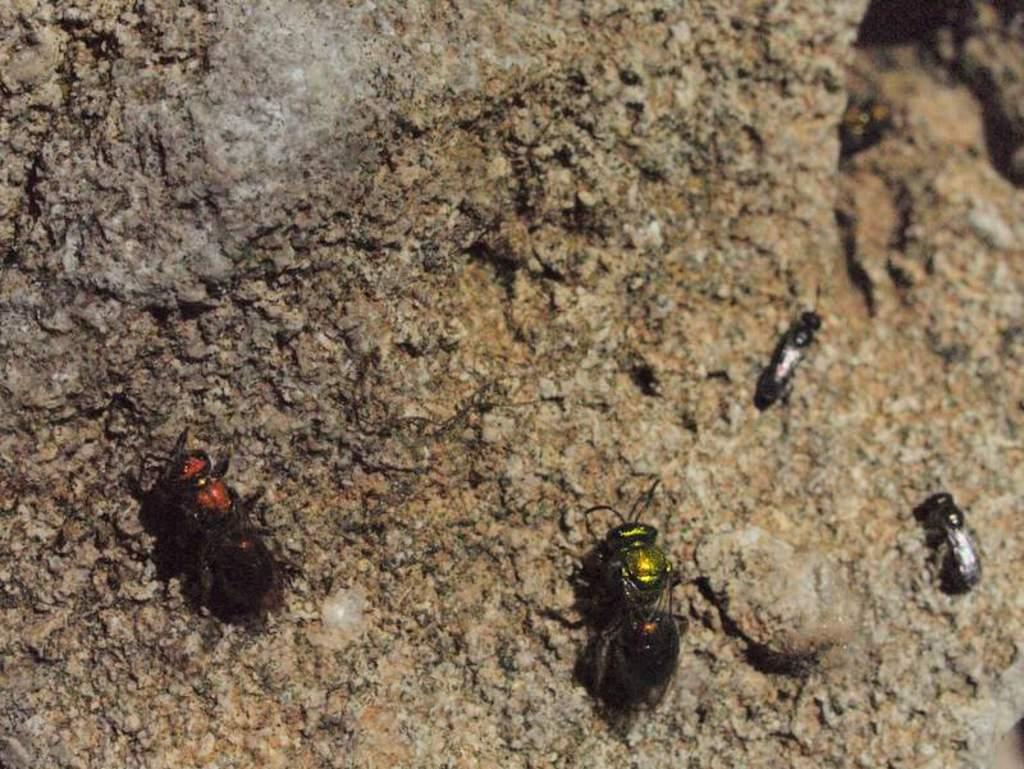What type of creatures can be seen on the surface in the image? There are insects on the surface in the image. What type of bottle is visible in the image? There is no bottle present in the image; it only features insects on a surface. 